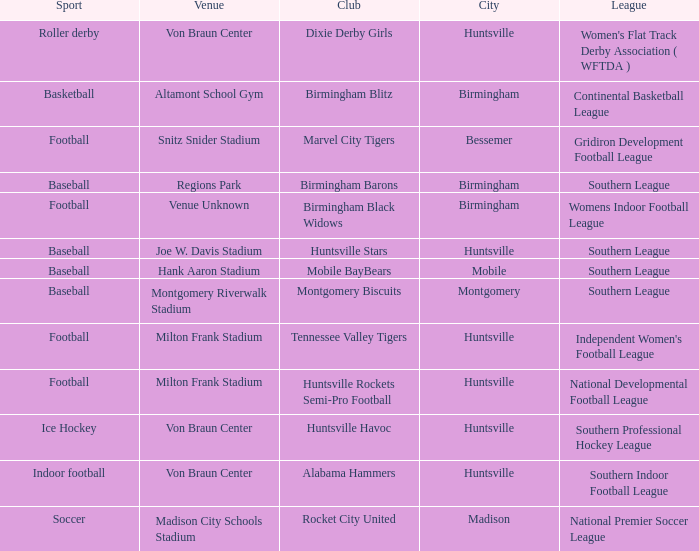Which venue held a basketball team? Altamont School Gym. 